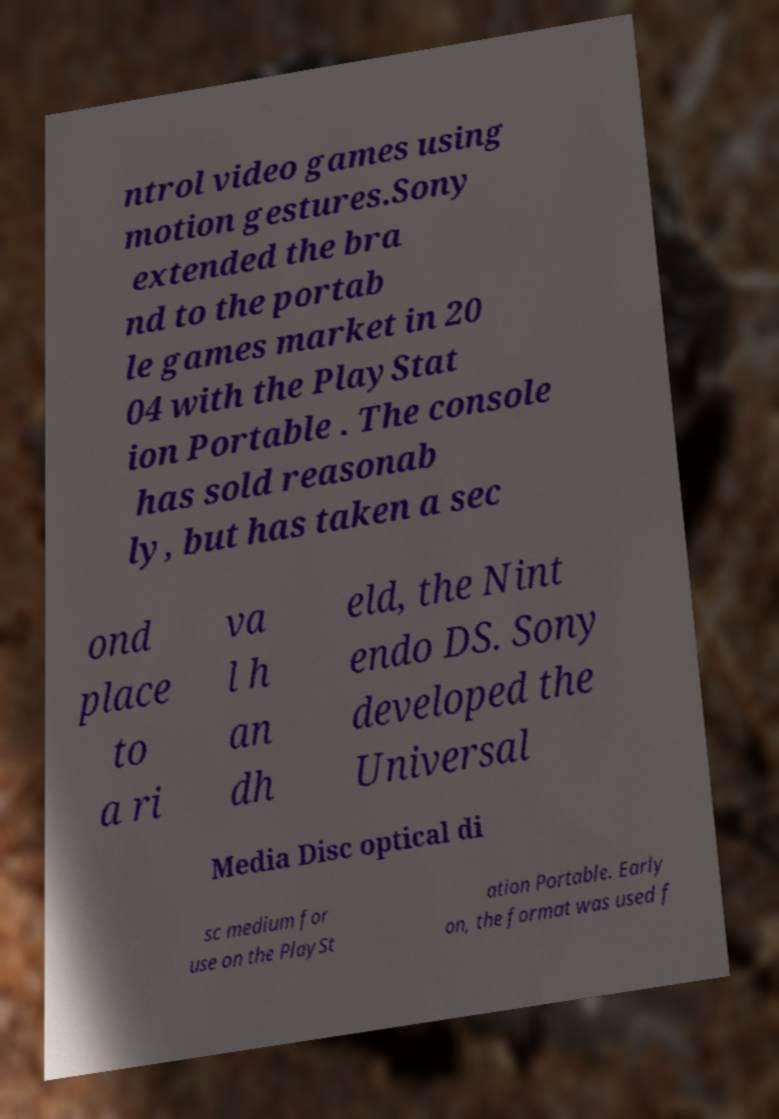Please identify and transcribe the text found in this image. ntrol video games using motion gestures.Sony extended the bra nd to the portab le games market in 20 04 with the PlayStat ion Portable . The console has sold reasonab ly, but has taken a sec ond place to a ri va l h an dh eld, the Nint endo DS. Sony developed the Universal Media Disc optical di sc medium for use on the PlaySt ation Portable. Early on, the format was used f 